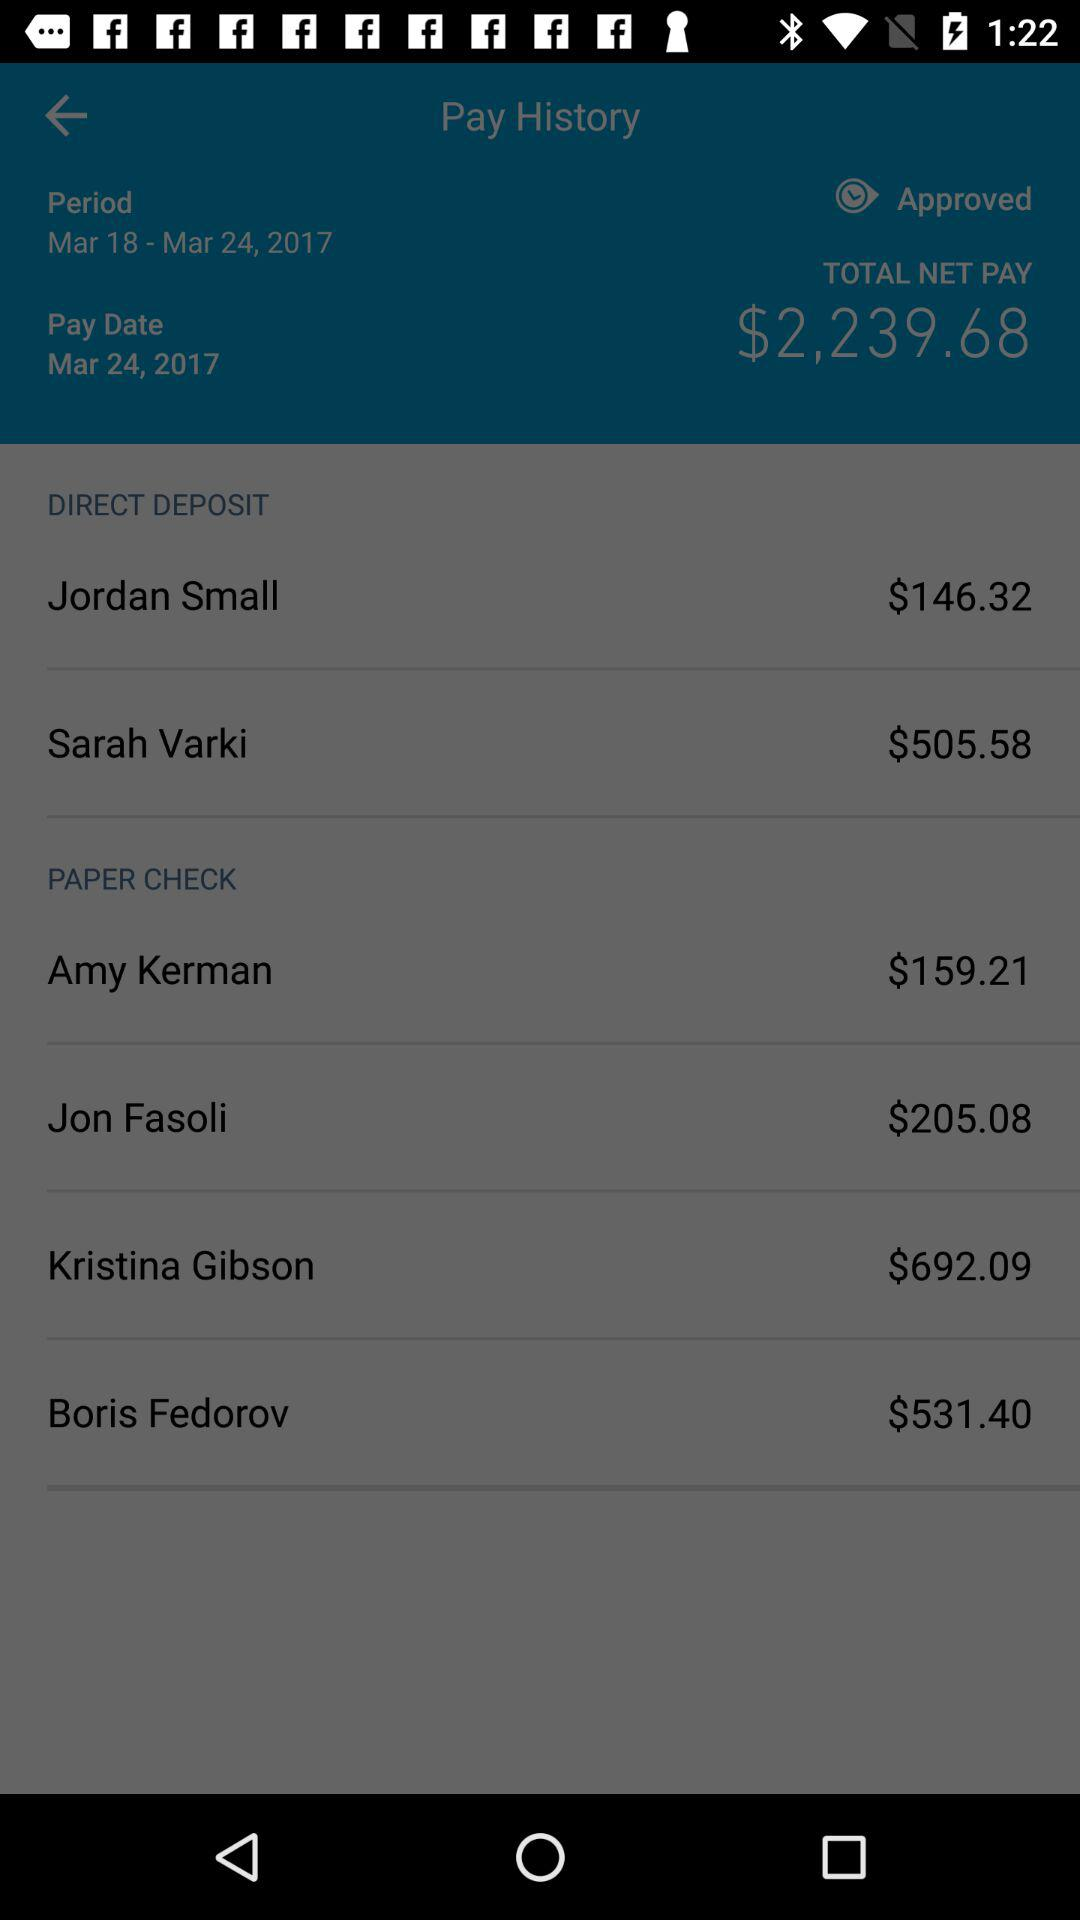What is the total net pay? The total net pay is $2,239.68. 